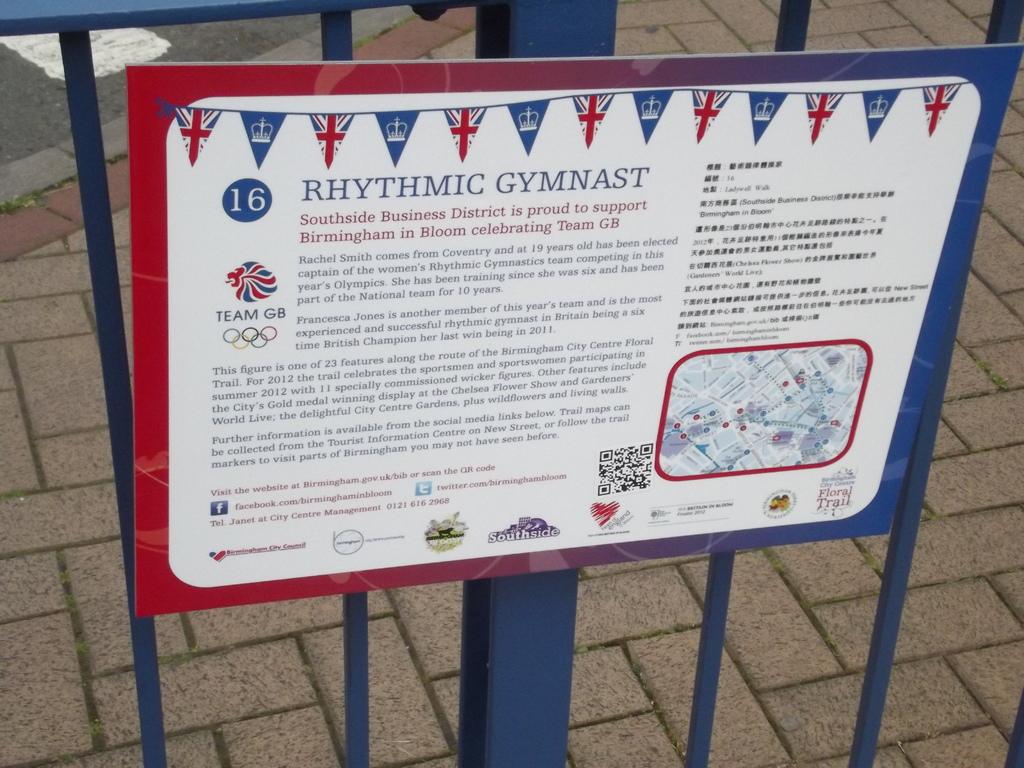What is this sign talking about?
Your response must be concise. Rhythmic gymnast. What is the number shown in the board?
Provide a succinct answer. 16. 